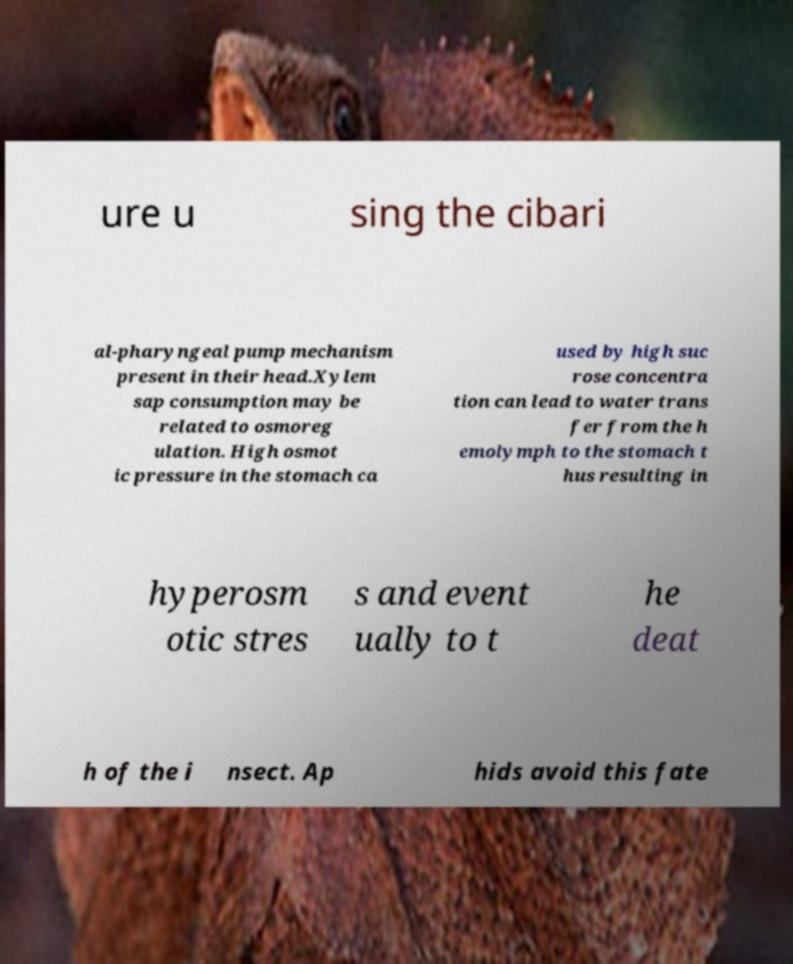Could you assist in decoding the text presented in this image and type it out clearly? ure u sing the cibari al-pharyngeal pump mechanism present in their head.Xylem sap consumption may be related to osmoreg ulation. High osmot ic pressure in the stomach ca used by high suc rose concentra tion can lead to water trans fer from the h emolymph to the stomach t hus resulting in hyperosm otic stres s and event ually to t he deat h of the i nsect. Ap hids avoid this fate 